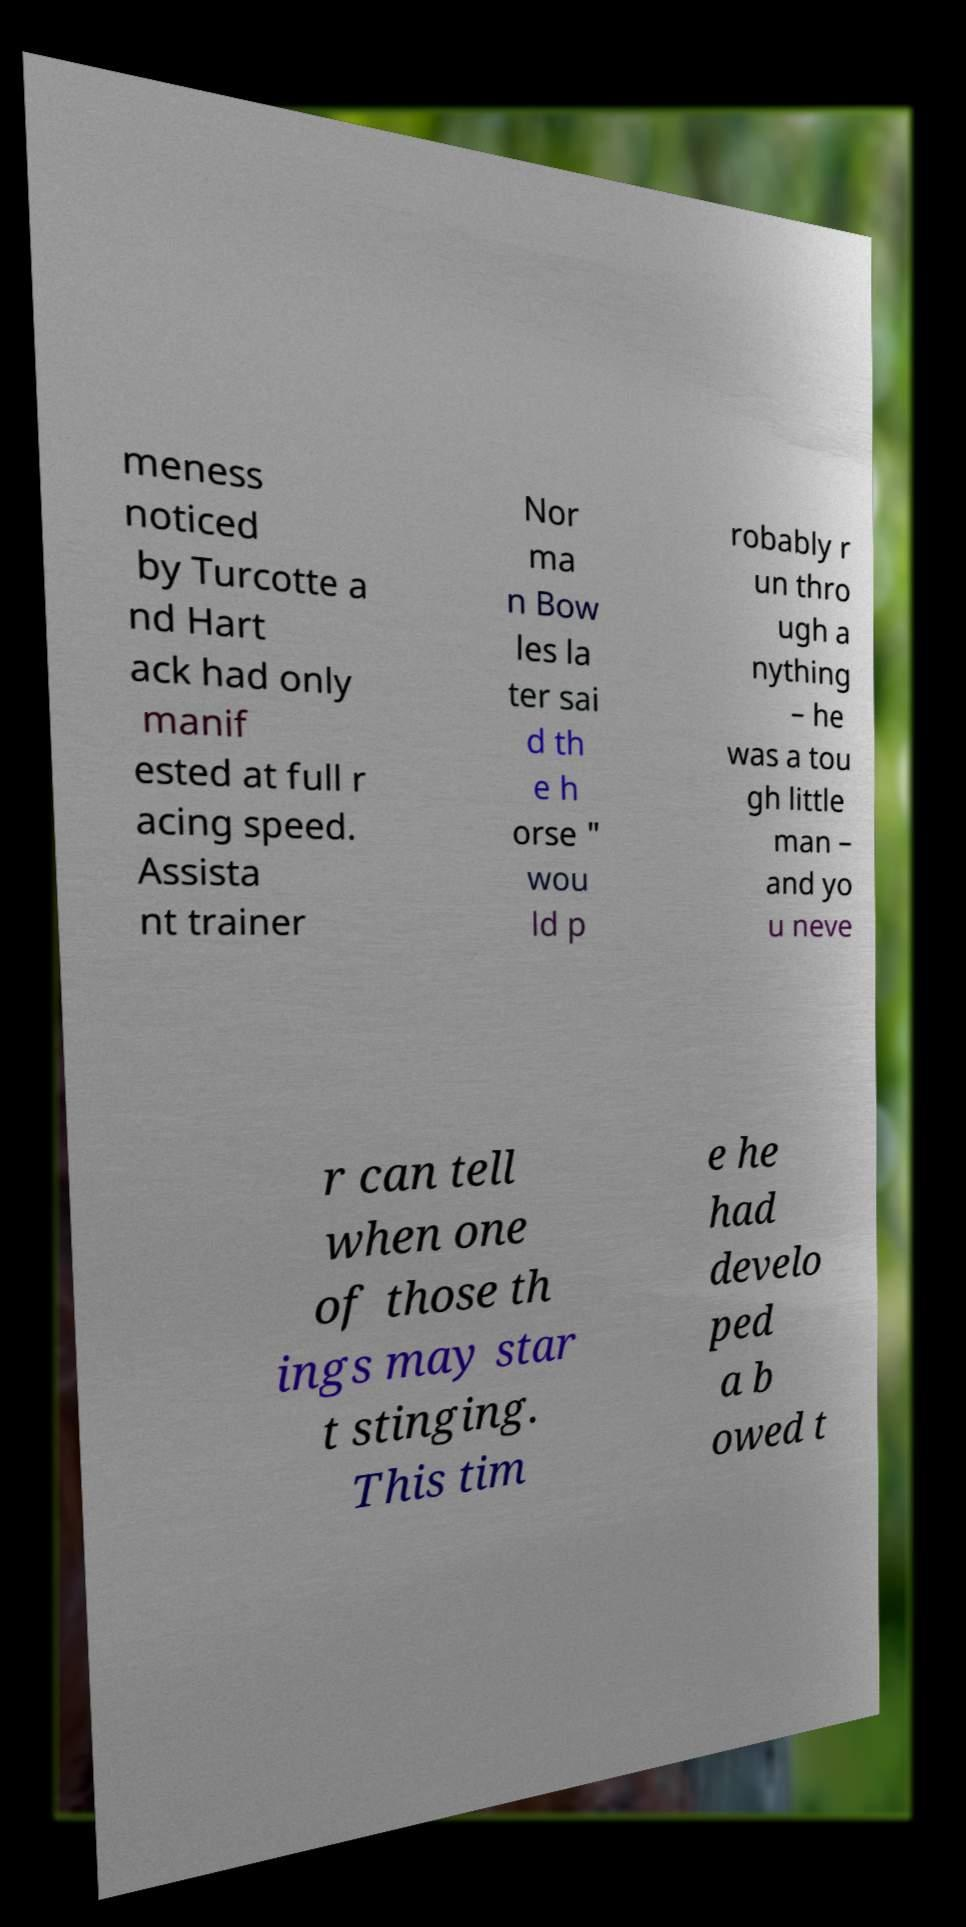Please identify and transcribe the text found in this image. meness noticed by Turcotte a nd Hart ack had only manif ested at full r acing speed. Assista nt trainer Nor ma n Bow les la ter sai d th e h orse " wou ld p robably r un thro ugh a nything – he was a tou gh little man – and yo u neve r can tell when one of those th ings may star t stinging. This tim e he had develo ped a b owed t 